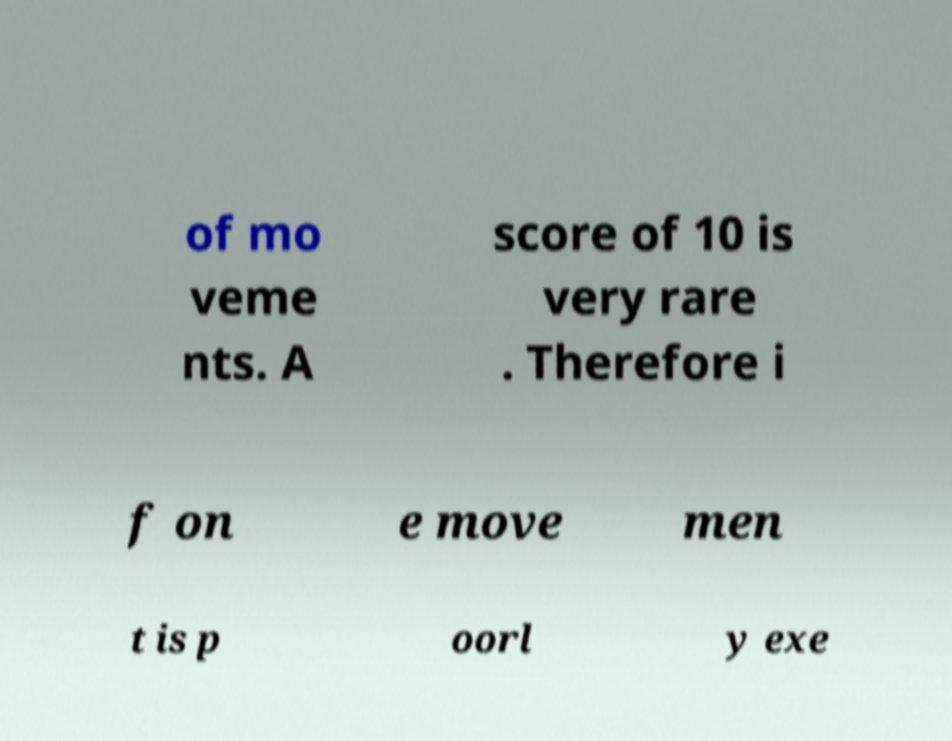There's text embedded in this image that I need extracted. Can you transcribe it verbatim? of mo veme nts. A score of 10 is very rare . Therefore i f on e move men t is p oorl y exe 